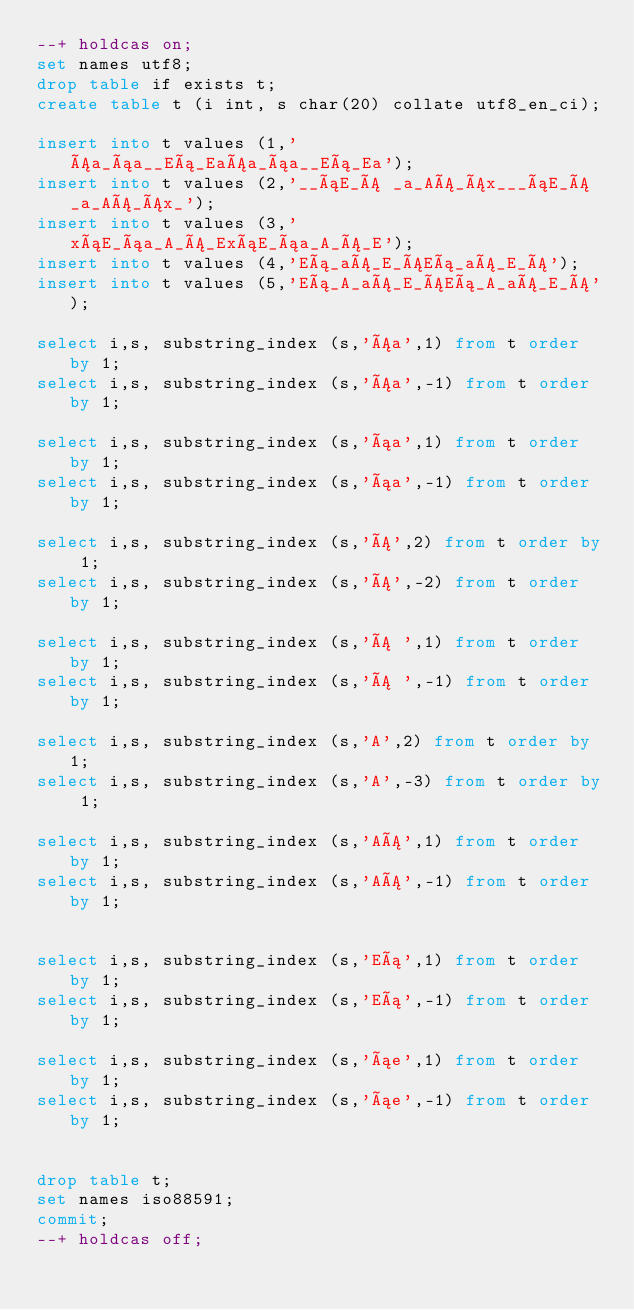Convert code to text. <code><loc_0><loc_0><loc_500><loc_500><_SQL_>--+ holdcas on;
set names utf8;
drop table if exists t;
create table t (i int, s char(20) collate utf8_en_ci);

insert into t values (1,'Áa_áa__Eá_EaÁa_áa__Eá_Ea');
insert into t values (2,'__áE_Á _a_AÁ_Áx___áE_Á _a_AÁ_Áx_');
insert into t values (3,'xáE_áa_A_Á_ExáE_áa_A_Á_E');
insert into t values (4,'Eá_aÁ_E_ÁEá_aÁ_E_Á');
insert into t values (5,'Eá_A_aÁ_E_ÁEá_A_aÁ_E_Á');

select i,s, substring_index (s,'Áa',1) from t order by 1;
select i,s, substring_index (s,'Áa',-1) from t order by 1;

select i,s, substring_index (s,'áa',1) from t order by 1;
select i,s, substring_index (s,'áa',-1) from t order by 1;

select i,s, substring_index (s,'Á',2) from t order by 1;
select i,s, substring_index (s,'Á',-2) from t order by 1;

select i,s, substring_index (s,'Á ',1) from t order by 1;
select i,s, substring_index (s,'Á ',-1) from t order by 1;

select i,s, substring_index (s,'A',2) from t order by 1;
select i,s, substring_index (s,'A',-3) from t order by 1;

select i,s, substring_index (s,'AÁ',1) from t order by 1;
select i,s, substring_index (s,'AÁ',-1) from t order by 1;


select i,s, substring_index (s,'Eá',1) from t order by 1;
select i,s, substring_index (s,'Eá',-1) from t order by 1;

select i,s, substring_index (s,'áe',1) from t order by 1;
select i,s, substring_index (s,'áe',-1) from t order by 1;


drop table t;
set names iso88591;
commit;
--+ holdcas off;
</code> 